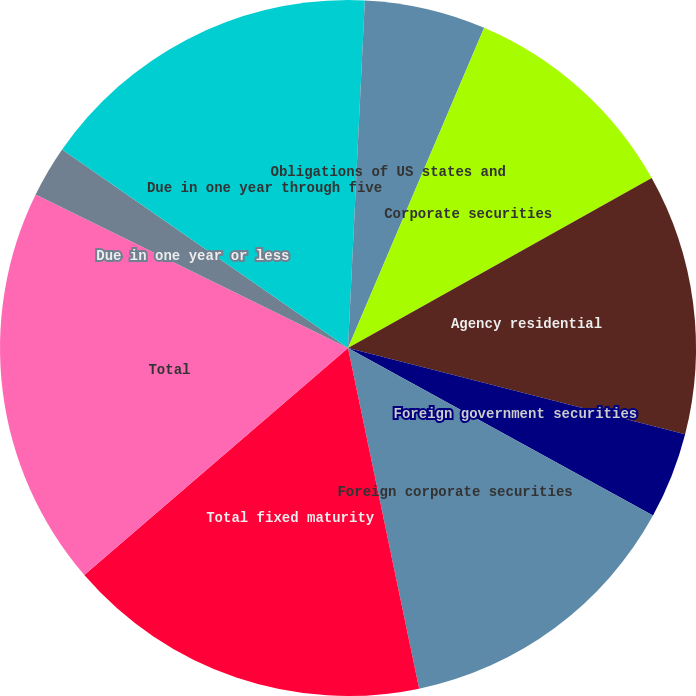Convert chart to OTSL. <chart><loc_0><loc_0><loc_500><loc_500><pie_chart><fcel>US Treasury securities and<fcel>Obligations of US states and<fcel>Corporate securities<fcel>Agency residential<fcel>Foreign government securities<fcel>Foreign corporate securities<fcel>Total fixed maturity<fcel>Total<fcel>Due in one year or less<fcel>Due in one year through five<nl><fcel>0.77%<fcel>5.63%<fcel>10.49%<fcel>12.11%<fcel>4.01%<fcel>13.73%<fcel>16.97%<fcel>18.59%<fcel>2.39%<fcel>15.35%<nl></chart> 